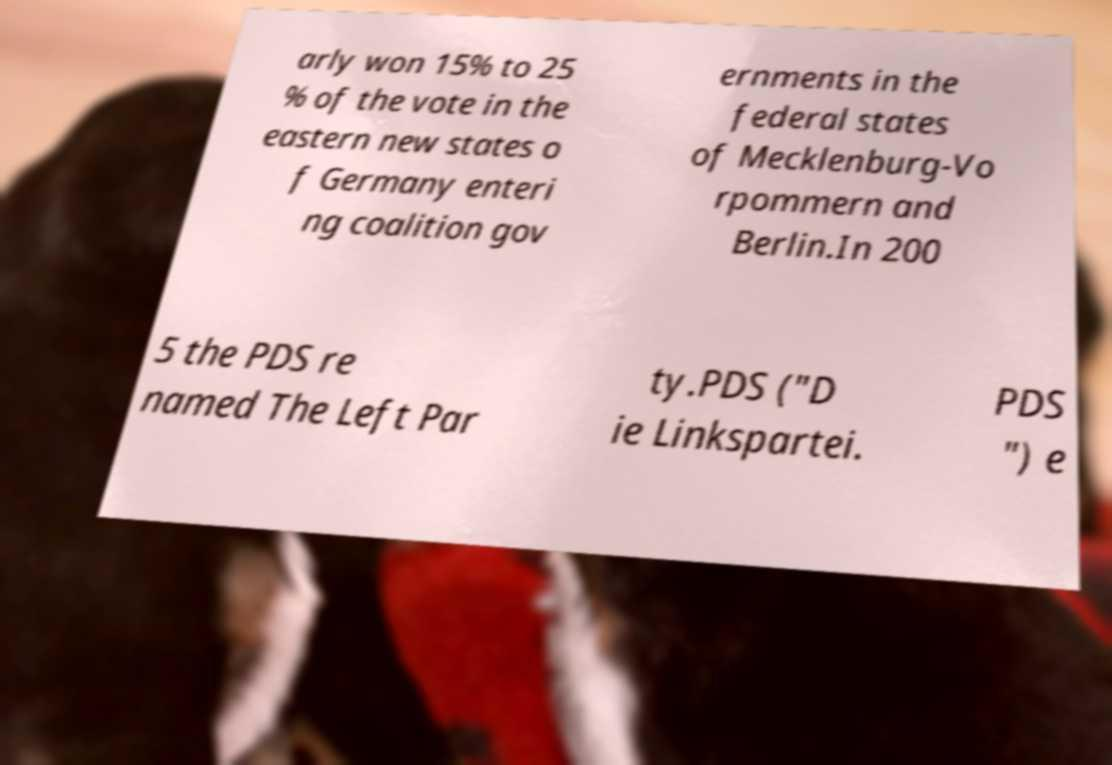There's text embedded in this image that I need extracted. Can you transcribe it verbatim? arly won 15% to 25 % of the vote in the eastern new states o f Germany enteri ng coalition gov ernments in the federal states of Mecklenburg-Vo rpommern and Berlin.In 200 5 the PDS re named The Left Par ty.PDS ("D ie Linkspartei. PDS ") e 